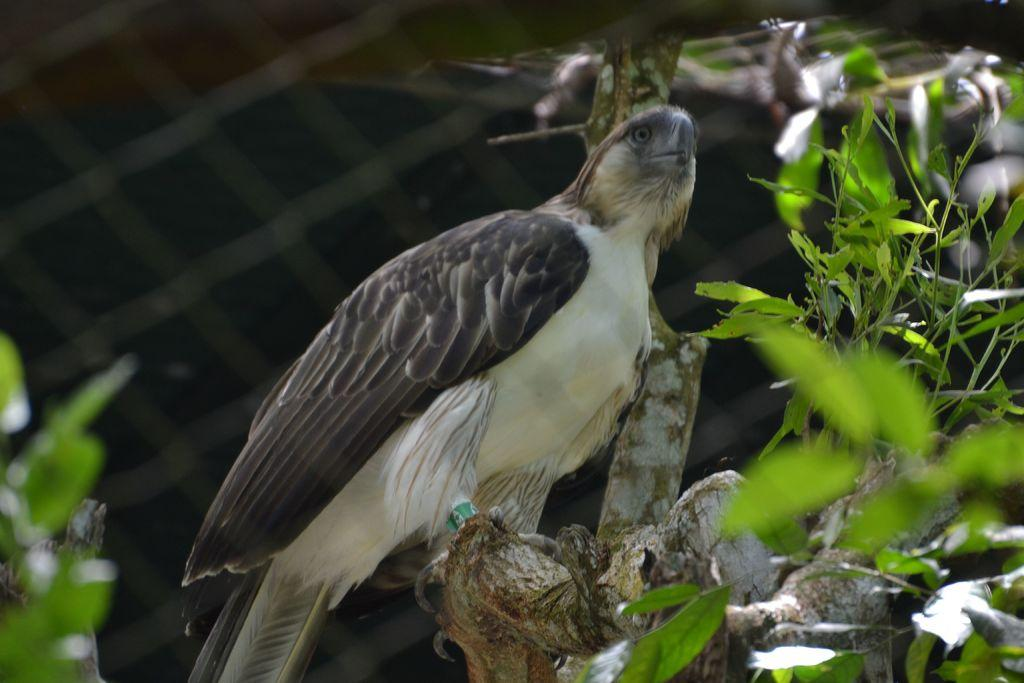What is located on the bark of a tree in the foreground of the image? There is a bird on the bark of a tree in the foreground of the image. What type of vegetation can be seen in the image? There are leaves in the left and right corners of the image. What can be seen in the background of the image? There is a mesh in the background of the image. What type of tooth is visible in the image? There is no tooth present in the image. How many flies can be seen in the image? There are no flies present in the image. 